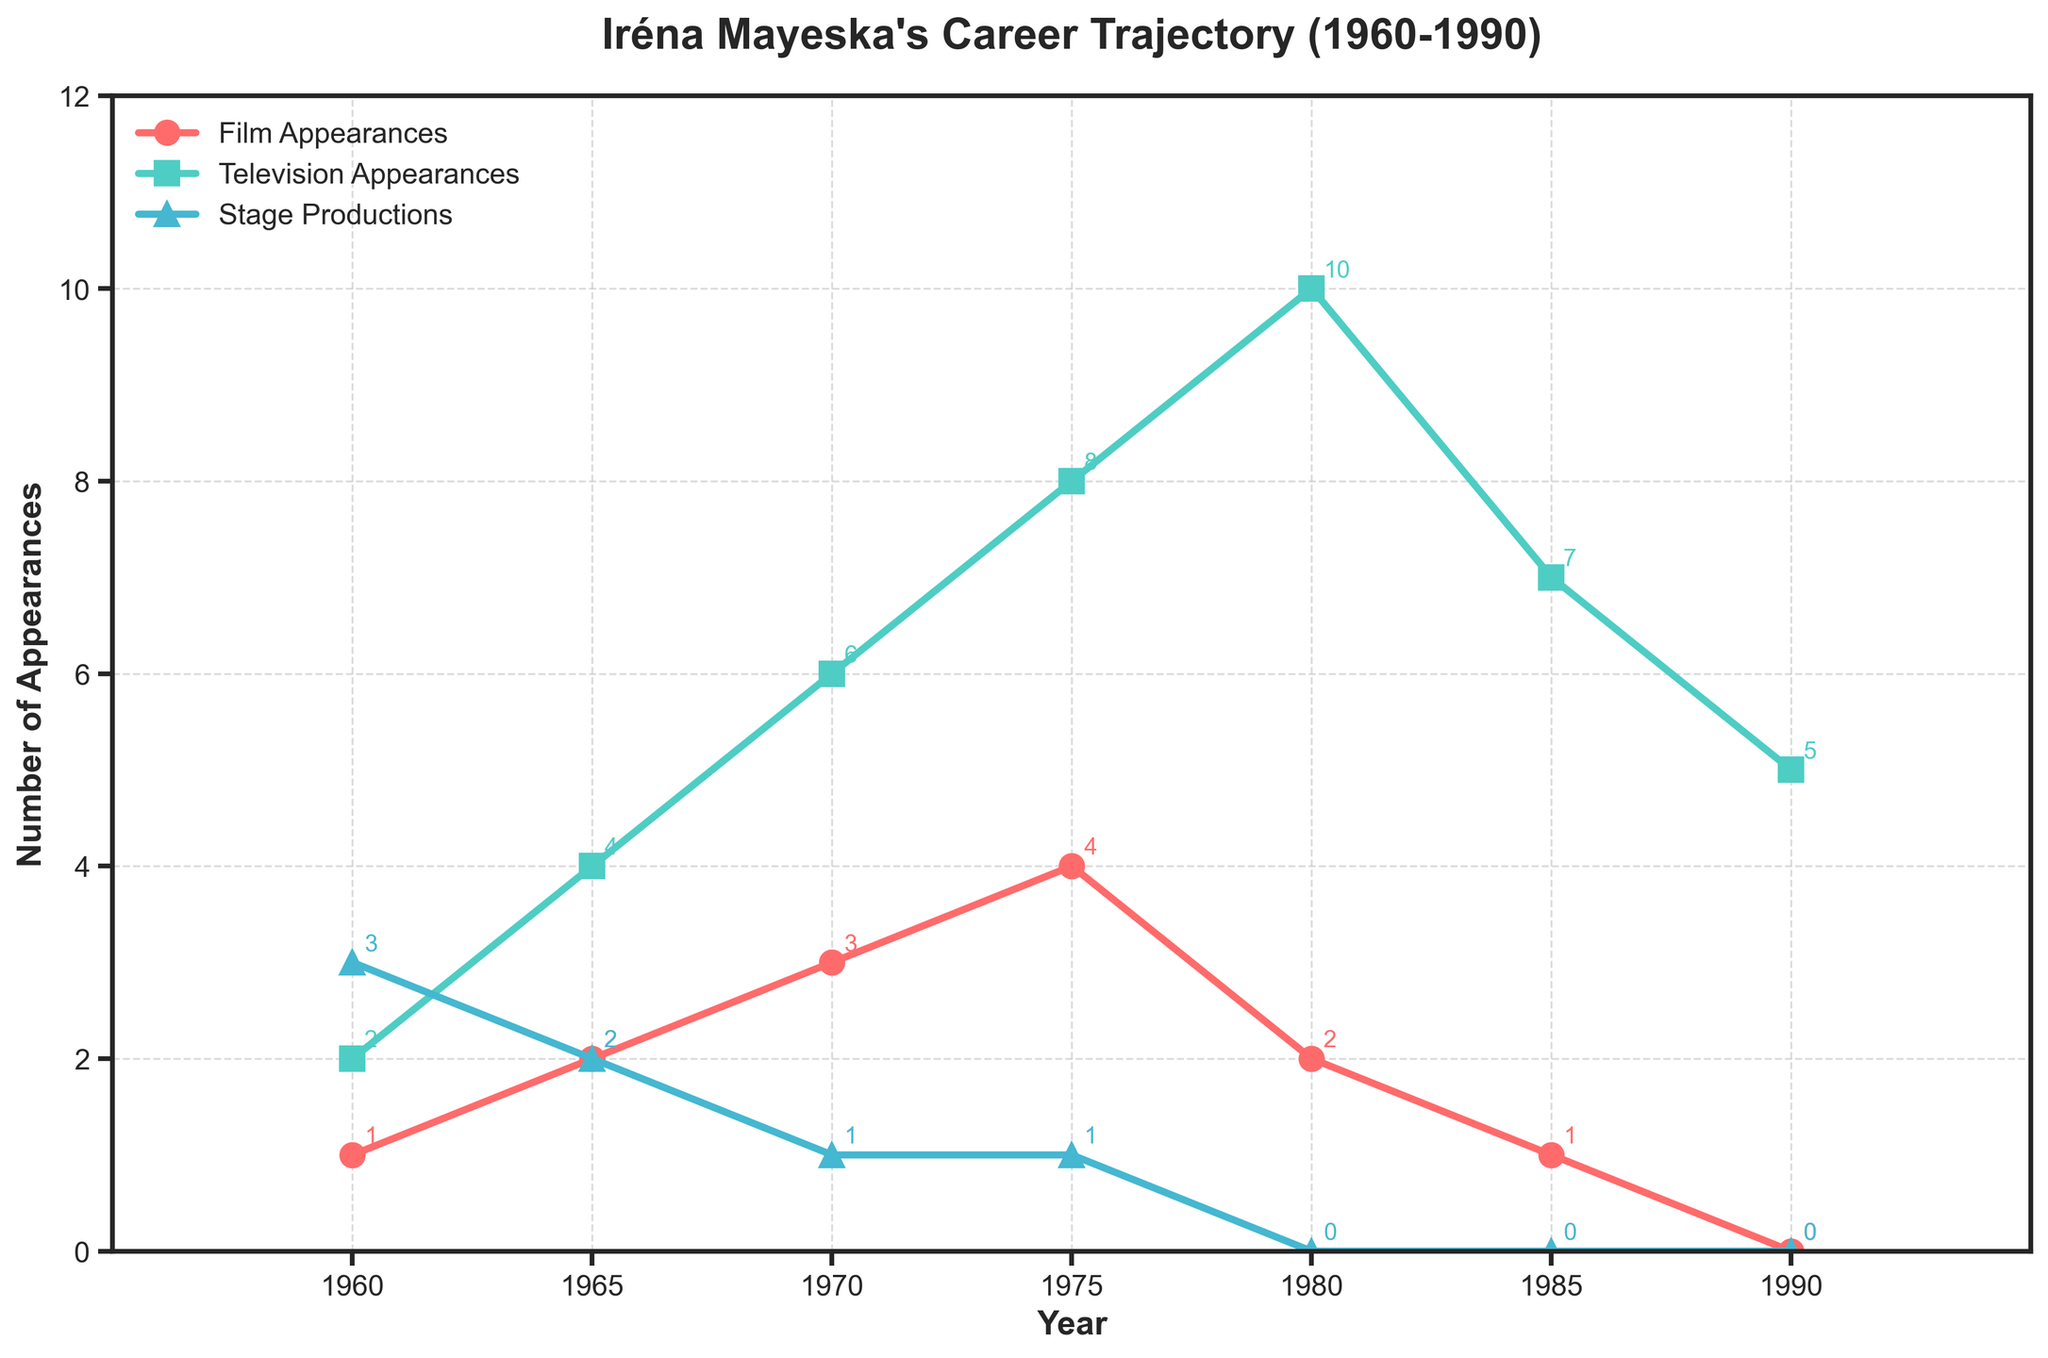What trend can be observed in Iréna Mayeska's film appearances from 1960 to 1990? The film appearances start at 1 in 1960, increase to a peak of 4 in 1975, then decrease steadily to 0 by 1990.
Answer: Her film appearances peaked in 1975 and then declined How do Iréna Mayeska's television appearances compare to her stage productions in the year 1980? In 1980, her television appearances were 10 while her stage productions were 0, showing she focused more on television that year.
Answer: She appeared more on television What is the difference between the highest number of television appearances and the lowest number of film appearances? The highest television appearances are 10 in 1980, and the lowest film appearances are 0 in 1990. The difference is 10 - 0 = 10.
Answer: 10 Between 1970 and 1975, do Iréna Mayeska's stage productions increase, decrease, or stay the same? In 1970, she had 1 stage production, and it remains the same in 1975 with 1 stage production.
Answer: Stay the same What can be inferred about Iréna Mayeska's focus in the 1980s compared to the 1960s? In the 1960s, she had multiple engagements in film, television, and stage. In the 1980s, she appeared less in films and did no stage work, focusing more on television appearances.
Answer: Her focus shifted to television How many total film appearances did Iréna Mayeska have from 1960 to 1990? Summing up the film appearances from the data (1+2+3+4+2+1+0), the total is 13.
Answer: 13 What is the overall trend of Iréna Mayeska's stage productions from 1960 to 1990? The stage productions start at 3 in 1960, decrease to 2 in 1965, then to 1 in 1970, remain at 1 until 1975, and drop to 0 by 1980, staying at 0 thereafter.
Answer: Declining trend Which year shows the maximum combined appearances across film, television, and stage productions? In 1975, the combined appearances are: 4 (film) + 8 (television) + 1 (stage) = 13, which is the highest.
Answer: 1975 By what factor did Iréna Mayeska's television appearances increase from 1960 to 1980? In 1960, she had 2 television appearances, and in 1980, she had 10. The factor increase is 10/2 = 5.
Answer: 5 In which year did Iréna Mayeska have the same number of film and stage productions? In 1965, she had 2 film appearances and 2 stage productions.
Answer: 1965 